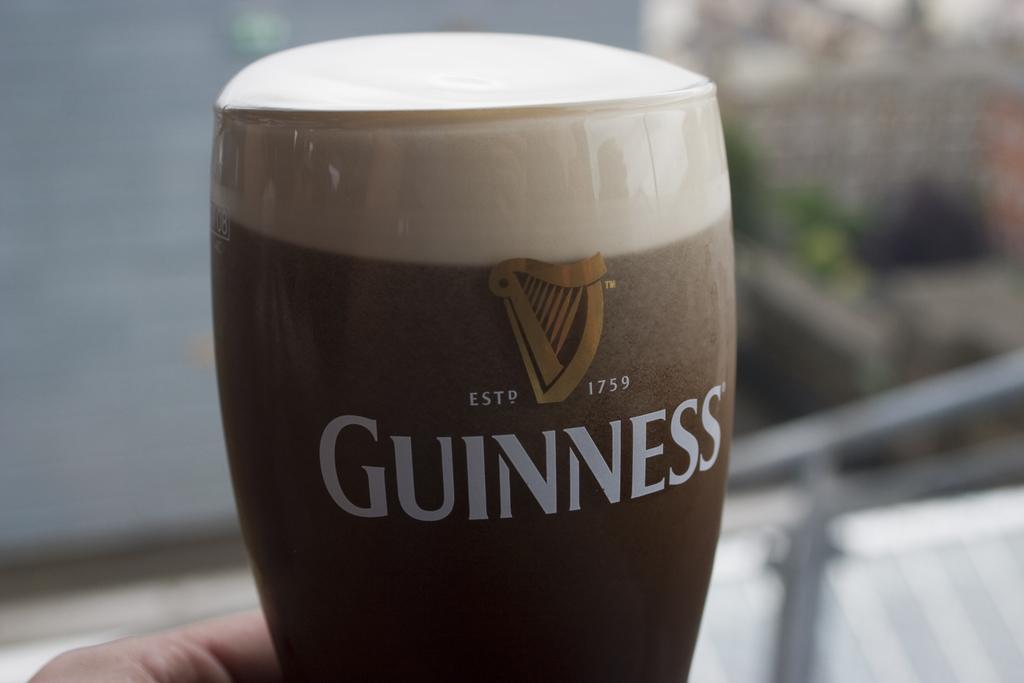Please provide a concise description of this image. In this picture we can see a person is holding a glass with some liquid. Only person hand is visible. Behind the glass there is the blurred background. 